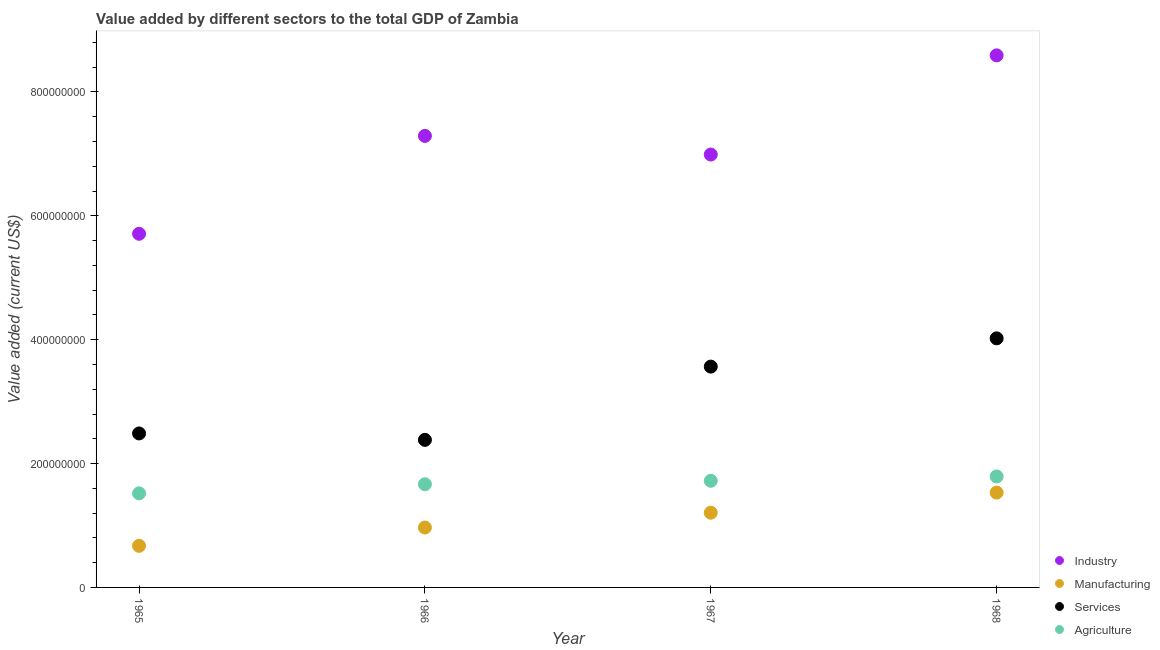Is the number of dotlines equal to the number of legend labels?
Keep it short and to the point. Yes. What is the value added by manufacturing sector in 1968?
Your response must be concise. 1.53e+08. Across all years, what is the maximum value added by services sector?
Provide a short and direct response. 4.02e+08. Across all years, what is the minimum value added by industrial sector?
Your answer should be very brief. 5.71e+08. In which year was the value added by services sector maximum?
Offer a terse response. 1968. In which year was the value added by industrial sector minimum?
Make the answer very short. 1965. What is the total value added by services sector in the graph?
Your answer should be compact. 1.25e+09. What is the difference between the value added by services sector in 1966 and that in 1967?
Give a very brief answer. -1.18e+08. What is the difference between the value added by industrial sector in 1968 and the value added by agricultural sector in 1967?
Your response must be concise. 6.87e+08. What is the average value added by agricultural sector per year?
Your answer should be compact. 1.67e+08. In the year 1967, what is the difference between the value added by industrial sector and value added by agricultural sector?
Ensure brevity in your answer.  5.27e+08. What is the ratio of the value added by services sector in 1965 to that in 1967?
Your answer should be very brief. 0.7. Is the value added by manufacturing sector in 1965 less than that in 1967?
Keep it short and to the point. Yes. Is the difference between the value added by services sector in 1965 and 1967 greater than the difference between the value added by industrial sector in 1965 and 1967?
Your answer should be compact. Yes. What is the difference between the highest and the second highest value added by manufacturing sector?
Give a very brief answer. 3.25e+07. What is the difference between the highest and the lowest value added by services sector?
Make the answer very short. 1.64e+08. Is the value added by services sector strictly greater than the value added by agricultural sector over the years?
Give a very brief answer. Yes. How many dotlines are there?
Your answer should be very brief. 4. How many years are there in the graph?
Make the answer very short. 4. What is the difference between two consecutive major ticks on the Y-axis?
Provide a succinct answer. 2.00e+08. Are the values on the major ticks of Y-axis written in scientific E-notation?
Make the answer very short. No. What is the title of the graph?
Provide a short and direct response. Value added by different sectors to the total GDP of Zambia. Does "Natural Gas" appear as one of the legend labels in the graph?
Your answer should be compact. No. What is the label or title of the X-axis?
Keep it short and to the point. Year. What is the label or title of the Y-axis?
Make the answer very short. Value added (current US$). What is the Value added (current US$) in Industry in 1965?
Your answer should be compact. 5.71e+08. What is the Value added (current US$) of Manufacturing in 1965?
Keep it short and to the point. 6.72e+07. What is the Value added (current US$) of Services in 1965?
Keep it short and to the point. 2.49e+08. What is the Value added (current US$) in Agriculture in 1965?
Provide a succinct answer. 1.52e+08. What is the Value added (current US$) in Industry in 1966?
Offer a very short reply. 7.29e+08. What is the Value added (current US$) in Manufacturing in 1966?
Offer a terse response. 9.67e+07. What is the Value added (current US$) in Services in 1966?
Your answer should be very brief. 2.38e+08. What is the Value added (current US$) of Agriculture in 1966?
Your answer should be very brief. 1.67e+08. What is the Value added (current US$) in Industry in 1967?
Offer a very short reply. 6.99e+08. What is the Value added (current US$) of Manufacturing in 1967?
Give a very brief answer. 1.21e+08. What is the Value added (current US$) of Services in 1967?
Provide a succinct answer. 3.57e+08. What is the Value added (current US$) in Agriculture in 1967?
Give a very brief answer. 1.72e+08. What is the Value added (current US$) in Industry in 1968?
Keep it short and to the point. 8.59e+08. What is the Value added (current US$) of Manufacturing in 1968?
Offer a very short reply. 1.53e+08. What is the Value added (current US$) of Services in 1968?
Provide a succinct answer. 4.02e+08. What is the Value added (current US$) of Agriculture in 1968?
Keep it short and to the point. 1.79e+08. Across all years, what is the maximum Value added (current US$) of Industry?
Keep it short and to the point. 8.59e+08. Across all years, what is the maximum Value added (current US$) of Manufacturing?
Your response must be concise. 1.53e+08. Across all years, what is the maximum Value added (current US$) in Services?
Your answer should be compact. 4.02e+08. Across all years, what is the maximum Value added (current US$) of Agriculture?
Give a very brief answer. 1.79e+08. Across all years, what is the minimum Value added (current US$) in Industry?
Give a very brief answer. 5.71e+08. Across all years, what is the minimum Value added (current US$) of Manufacturing?
Your answer should be compact. 6.72e+07. Across all years, what is the minimum Value added (current US$) in Services?
Provide a short and direct response. 2.38e+08. Across all years, what is the minimum Value added (current US$) of Agriculture?
Provide a short and direct response. 1.52e+08. What is the total Value added (current US$) in Industry in the graph?
Your response must be concise. 2.86e+09. What is the total Value added (current US$) in Manufacturing in the graph?
Offer a terse response. 4.38e+08. What is the total Value added (current US$) of Services in the graph?
Give a very brief answer. 1.25e+09. What is the total Value added (current US$) in Agriculture in the graph?
Give a very brief answer. 6.70e+08. What is the difference between the Value added (current US$) of Industry in 1965 and that in 1966?
Your answer should be very brief. -1.58e+08. What is the difference between the Value added (current US$) in Manufacturing in 1965 and that in 1966?
Your answer should be very brief. -2.95e+07. What is the difference between the Value added (current US$) in Services in 1965 and that in 1966?
Provide a succinct answer. 1.04e+07. What is the difference between the Value added (current US$) in Agriculture in 1965 and that in 1966?
Make the answer very short. -1.47e+07. What is the difference between the Value added (current US$) of Industry in 1965 and that in 1967?
Ensure brevity in your answer.  -1.28e+08. What is the difference between the Value added (current US$) in Manufacturing in 1965 and that in 1967?
Provide a short and direct response. -5.35e+07. What is the difference between the Value added (current US$) in Services in 1965 and that in 1967?
Your answer should be very brief. -1.08e+08. What is the difference between the Value added (current US$) of Agriculture in 1965 and that in 1967?
Keep it short and to the point. -2.03e+07. What is the difference between the Value added (current US$) in Industry in 1965 and that in 1968?
Ensure brevity in your answer.  -2.88e+08. What is the difference between the Value added (current US$) of Manufacturing in 1965 and that in 1968?
Give a very brief answer. -8.60e+07. What is the difference between the Value added (current US$) of Services in 1965 and that in 1968?
Your answer should be very brief. -1.54e+08. What is the difference between the Value added (current US$) in Agriculture in 1965 and that in 1968?
Your response must be concise. -2.73e+07. What is the difference between the Value added (current US$) in Industry in 1966 and that in 1967?
Give a very brief answer. 3.01e+07. What is the difference between the Value added (current US$) in Manufacturing in 1966 and that in 1967?
Provide a succinct answer. -2.39e+07. What is the difference between the Value added (current US$) in Services in 1966 and that in 1967?
Offer a terse response. -1.18e+08. What is the difference between the Value added (current US$) in Agriculture in 1966 and that in 1967?
Your response must be concise. -5.60e+06. What is the difference between the Value added (current US$) in Industry in 1966 and that in 1968?
Provide a succinct answer. -1.30e+08. What is the difference between the Value added (current US$) of Manufacturing in 1966 and that in 1968?
Make the answer very short. -5.64e+07. What is the difference between the Value added (current US$) in Services in 1966 and that in 1968?
Your response must be concise. -1.64e+08. What is the difference between the Value added (current US$) of Agriculture in 1966 and that in 1968?
Provide a succinct answer. -1.26e+07. What is the difference between the Value added (current US$) in Industry in 1967 and that in 1968?
Provide a succinct answer. -1.60e+08. What is the difference between the Value added (current US$) in Manufacturing in 1967 and that in 1968?
Your response must be concise. -3.25e+07. What is the difference between the Value added (current US$) of Services in 1967 and that in 1968?
Your answer should be very brief. -4.56e+07. What is the difference between the Value added (current US$) in Agriculture in 1967 and that in 1968?
Keep it short and to the point. -7.00e+06. What is the difference between the Value added (current US$) in Industry in 1965 and the Value added (current US$) in Manufacturing in 1966?
Your answer should be very brief. 4.74e+08. What is the difference between the Value added (current US$) in Industry in 1965 and the Value added (current US$) in Services in 1966?
Make the answer very short. 3.33e+08. What is the difference between the Value added (current US$) of Industry in 1965 and the Value added (current US$) of Agriculture in 1966?
Provide a succinct answer. 4.04e+08. What is the difference between the Value added (current US$) of Manufacturing in 1965 and the Value added (current US$) of Services in 1966?
Your answer should be very brief. -1.71e+08. What is the difference between the Value added (current US$) in Manufacturing in 1965 and the Value added (current US$) in Agriculture in 1966?
Make the answer very short. -9.94e+07. What is the difference between the Value added (current US$) in Services in 1965 and the Value added (current US$) in Agriculture in 1966?
Offer a terse response. 8.20e+07. What is the difference between the Value added (current US$) of Industry in 1965 and the Value added (current US$) of Manufacturing in 1967?
Your response must be concise. 4.50e+08. What is the difference between the Value added (current US$) of Industry in 1965 and the Value added (current US$) of Services in 1967?
Ensure brevity in your answer.  2.14e+08. What is the difference between the Value added (current US$) in Industry in 1965 and the Value added (current US$) in Agriculture in 1967?
Offer a terse response. 3.99e+08. What is the difference between the Value added (current US$) in Manufacturing in 1965 and the Value added (current US$) in Services in 1967?
Give a very brief answer. -2.89e+08. What is the difference between the Value added (current US$) of Manufacturing in 1965 and the Value added (current US$) of Agriculture in 1967?
Make the answer very short. -1.05e+08. What is the difference between the Value added (current US$) of Services in 1965 and the Value added (current US$) of Agriculture in 1967?
Offer a very short reply. 7.64e+07. What is the difference between the Value added (current US$) of Industry in 1965 and the Value added (current US$) of Manufacturing in 1968?
Provide a succinct answer. 4.18e+08. What is the difference between the Value added (current US$) of Industry in 1965 and the Value added (current US$) of Services in 1968?
Keep it short and to the point. 1.69e+08. What is the difference between the Value added (current US$) in Industry in 1965 and the Value added (current US$) in Agriculture in 1968?
Make the answer very short. 3.92e+08. What is the difference between the Value added (current US$) of Manufacturing in 1965 and the Value added (current US$) of Services in 1968?
Ensure brevity in your answer.  -3.35e+08. What is the difference between the Value added (current US$) of Manufacturing in 1965 and the Value added (current US$) of Agriculture in 1968?
Ensure brevity in your answer.  -1.12e+08. What is the difference between the Value added (current US$) of Services in 1965 and the Value added (current US$) of Agriculture in 1968?
Give a very brief answer. 6.94e+07. What is the difference between the Value added (current US$) of Industry in 1966 and the Value added (current US$) of Manufacturing in 1967?
Provide a short and direct response. 6.08e+08. What is the difference between the Value added (current US$) in Industry in 1966 and the Value added (current US$) in Services in 1967?
Offer a very short reply. 3.73e+08. What is the difference between the Value added (current US$) in Industry in 1966 and the Value added (current US$) in Agriculture in 1967?
Offer a terse response. 5.57e+08. What is the difference between the Value added (current US$) of Manufacturing in 1966 and the Value added (current US$) of Services in 1967?
Give a very brief answer. -2.60e+08. What is the difference between the Value added (current US$) in Manufacturing in 1966 and the Value added (current US$) in Agriculture in 1967?
Keep it short and to the point. -7.55e+07. What is the difference between the Value added (current US$) of Services in 1966 and the Value added (current US$) of Agriculture in 1967?
Your response must be concise. 6.61e+07. What is the difference between the Value added (current US$) of Industry in 1966 and the Value added (current US$) of Manufacturing in 1968?
Your response must be concise. 5.76e+08. What is the difference between the Value added (current US$) of Industry in 1966 and the Value added (current US$) of Services in 1968?
Ensure brevity in your answer.  3.27e+08. What is the difference between the Value added (current US$) of Industry in 1966 and the Value added (current US$) of Agriculture in 1968?
Your answer should be compact. 5.50e+08. What is the difference between the Value added (current US$) of Manufacturing in 1966 and the Value added (current US$) of Services in 1968?
Your response must be concise. -3.05e+08. What is the difference between the Value added (current US$) of Manufacturing in 1966 and the Value added (current US$) of Agriculture in 1968?
Your answer should be compact. -8.25e+07. What is the difference between the Value added (current US$) in Services in 1966 and the Value added (current US$) in Agriculture in 1968?
Keep it short and to the point. 5.91e+07. What is the difference between the Value added (current US$) of Industry in 1967 and the Value added (current US$) of Manufacturing in 1968?
Keep it short and to the point. 5.46e+08. What is the difference between the Value added (current US$) in Industry in 1967 and the Value added (current US$) in Services in 1968?
Offer a very short reply. 2.97e+08. What is the difference between the Value added (current US$) in Industry in 1967 and the Value added (current US$) in Agriculture in 1968?
Your response must be concise. 5.20e+08. What is the difference between the Value added (current US$) in Manufacturing in 1967 and the Value added (current US$) in Services in 1968?
Your answer should be compact. -2.82e+08. What is the difference between the Value added (current US$) in Manufacturing in 1967 and the Value added (current US$) in Agriculture in 1968?
Keep it short and to the point. -5.85e+07. What is the difference between the Value added (current US$) of Services in 1967 and the Value added (current US$) of Agriculture in 1968?
Provide a succinct answer. 1.77e+08. What is the average Value added (current US$) of Industry per year?
Your response must be concise. 7.15e+08. What is the average Value added (current US$) of Manufacturing per year?
Your response must be concise. 1.09e+08. What is the average Value added (current US$) of Services per year?
Make the answer very short. 3.11e+08. What is the average Value added (current US$) in Agriculture per year?
Make the answer very short. 1.67e+08. In the year 1965, what is the difference between the Value added (current US$) of Industry and Value added (current US$) of Manufacturing?
Offer a very short reply. 5.04e+08. In the year 1965, what is the difference between the Value added (current US$) of Industry and Value added (current US$) of Services?
Offer a very short reply. 3.22e+08. In the year 1965, what is the difference between the Value added (current US$) of Industry and Value added (current US$) of Agriculture?
Your answer should be compact. 4.19e+08. In the year 1965, what is the difference between the Value added (current US$) in Manufacturing and Value added (current US$) in Services?
Your answer should be compact. -1.81e+08. In the year 1965, what is the difference between the Value added (current US$) in Manufacturing and Value added (current US$) in Agriculture?
Offer a terse response. -8.47e+07. In the year 1965, what is the difference between the Value added (current US$) in Services and Value added (current US$) in Agriculture?
Offer a terse response. 9.67e+07. In the year 1966, what is the difference between the Value added (current US$) in Industry and Value added (current US$) in Manufacturing?
Your answer should be very brief. 6.32e+08. In the year 1966, what is the difference between the Value added (current US$) of Industry and Value added (current US$) of Services?
Provide a succinct answer. 4.91e+08. In the year 1966, what is the difference between the Value added (current US$) of Industry and Value added (current US$) of Agriculture?
Provide a short and direct response. 5.63e+08. In the year 1966, what is the difference between the Value added (current US$) in Manufacturing and Value added (current US$) in Services?
Ensure brevity in your answer.  -1.42e+08. In the year 1966, what is the difference between the Value added (current US$) of Manufacturing and Value added (current US$) of Agriculture?
Provide a succinct answer. -6.99e+07. In the year 1966, what is the difference between the Value added (current US$) in Services and Value added (current US$) in Agriculture?
Make the answer very short. 7.17e+07. In the year 1967, what is the difference between the Value added (current US$) of Industry and Value added (current US$) of Manufacturing?
Your answer should be compact. 5.78e+08. In the year 1967, what is the difference between the Value added (current US$) of Industry and Value added (current US$) of Services?
Make the answer very short. 3.42e+08. In the year 1967, what is the difference between the Value added (current US$) of Industry and Value added (current US$) of Agriculture?
Your response must be concise. 5.27e+08. In the year 1967, what is the difference between the Value added (current US$) in Manufacturing and Value added (current US$) in Services?
Ensure brevity in your answer.  -2.36e+08. In the year 1967, what is the difference between the Value added (current US$) in Manufacturing and Value added (current US$) in Agriculture?
Give a very brief answer. -5.15e+07. In the year 1967, what is the difference between the Value added (current US$) in Services and Value added (current US$) in Agriculture?
Make the answer very short. 1.84e+08. In the year 1968, what is the difference between the Value added (current US$) of Industry and Value added (current US$) of Manufacturing?
Provide a short and direct response. 7.06e+08. In the year 1968, what is the difference between the Value added (current US$) of Industry and Value added (current US$) of Services?
Give a very brief answer. 4.57e+08. In the year 1968, what is the difference between the Value added (current US$) in Industry and Value added (current US$) in Agriculture?
Offer a very short reply. 6.80e+08. In the year 1968, what is the difference between the Value added (current US$) in Manufacturing and Value added (current US$) in Services?
Your answer should be compact. -2.49e+08. In the year 1968, what is the difference between the Value added (current US$) of Manufacturing and Value added (current US$) of Agriculture?
Your answer should be very brief. -2.60e+07. In the year 1968, what is the difference between the Value added (current US$) of Services and Value added (current US$) of Agriculture?
Offer a very short reply. 2.23e+08. What is the ratio of the Value added (current US$) in Industry in 1965 to that in 1966?
Provide a succinct answer. 0.78. What is the ratio of the Value added (current US$) in Manufacturing in 1965 to that in 1966?
Provide a short and direct response. 0.69. What is the ratio of the Value added (current US$) of Services in 1965 to that in 1966?
Your response must be concise. 1.04. What is the ratio of the Value added (current US$) of Agriculture in 1965 to that in 1966?
Ensure brevity in your answer.  0.91. What is the ratio of the Value added (current US$) in Industry in 1965 to that in 1967?
Your answer should be compact. 0.82. What is the ratio of the Value added (current US$) in Manufacturing in 1965 to that in 1967?
Your response must be concise. 0.56. What is the ratio of the Value added (current US$) in Services in 1965 to that in 1967?
Offer a terse response. 0.7. What is the ratio of the Value added (current US$) of Agriculture in 1965 to that in 1967?
Offer a very short reply. 0.88. What is the ratio of the Value added (current US$) of Industry in 1965 to that in 1968?
Make the answer very short. 0.66. What is the ratio of the Value added (current US$) in Manufacturing in 1965 to that in 1968?
Give a very brief answer. 0.44. What is the ratio of the Value added (current US$) in Services in 1965 to that in 1968?
Offer a very short reply. 0.62. What is the ratio of the Value added (current US$) of Agriculture in 1965 to that in 1968?
Offer a very short reply. 0.85. What is the ratio of the Value added (current US$) in Industry in 1966 to that in 1967?
Ensure brevity in your answer.  1.04. What is the ratio of the Value added (current US$) of Manufacturing in 1966 to that in 1967?
Give a very brief answer. 0.8. What is the ratio of the Value added (current US$) of Services in 1966 to that in 1967?
Ensure brevity in your answer.  0.67. What is the ratio of the Value added (current US$) of Agriculture in 1966 to that in 1967?
Ensure brevity in your answer.  0.97. What is the ratio of the Value added (current US$) of Industry in 1966 to that in 1968?
Offer a terse response. 0.85. What is the ratio of the Value added (current US$) in Manufacturing in 1966 to that in 1968?
Your answer should be compact. 0.63. What is the ratio of the Value added (current US$) in Services in 1966 to that in 1968?
Ensure brevity in your answer.  0.59. What is the ratio of the Value added (current US$) of Agriculture in 1966 to that in 1968?
Provide a succinct answer. 0.93. What is the ratio of the Value added (current US$) of Industry in 1967 to that in 1968?
Ensure brevity in your answer.  0.81. What is the ratio of the Value added (current US$) of Manufacturing in 1967 to that in 1968?
Keep it short and to the point. 0.79. What is the ratio of the Value added (current US$) in Services in 1967 to that in 1968?
Ensure brevity in your answer.  0.89. What is the ratio of the Value added (current US$) in Agriculture in 1967 to that in 1968?
Provide a short and direct response. 0.96. What is the difference between the highest and the second highest Value added (current US$) of Industry?
Offer a terse response. 1.30e+08. What is the difference between the highest and the second highest Value added (current US$) in Manufacturing?
Your response must be concise. 3.25e+07. What is the difference between the highest and the second highest Value added (current US$) in Services?
Offer a terse response. 4.56e+07. What is the difference between the highest and the second highest Value added (current US$) in Agriculture?
Keep it short and to the point. 7.00e+06. What is the difference between the highest and the lowest Value added (current US$) of Industry?
Keep it short and to the point. 2.88e+08. What is the difference between the highest and the lowest Value added (current US$) in Manufacturing?
Your answer should be very brief. 8.60e+07. What is the difference between the highest and the lowest Value added (current US$) of Services?
Make the answer very short. 1.64e+08. What is the difference between the highest and the lowest Value added (current US$) of Agriculture?
Provide a short and direct response. 2.73e+07. 